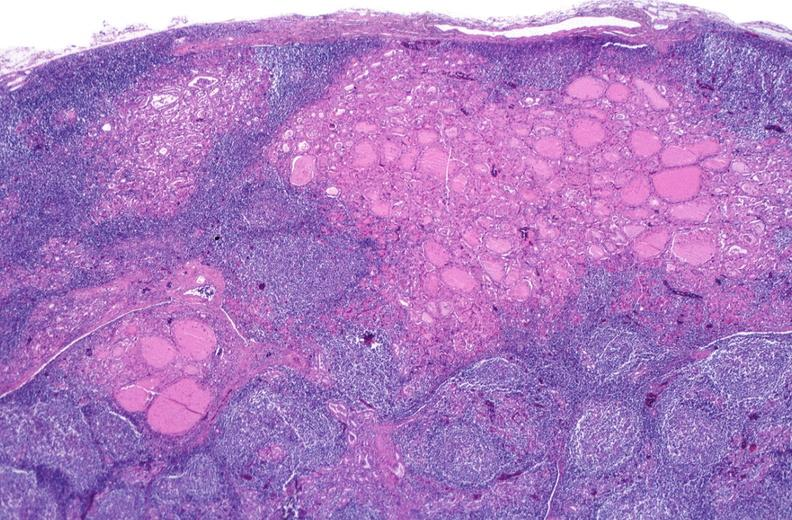what is present?
Answer the question using a single word or phrase. Endocrine 